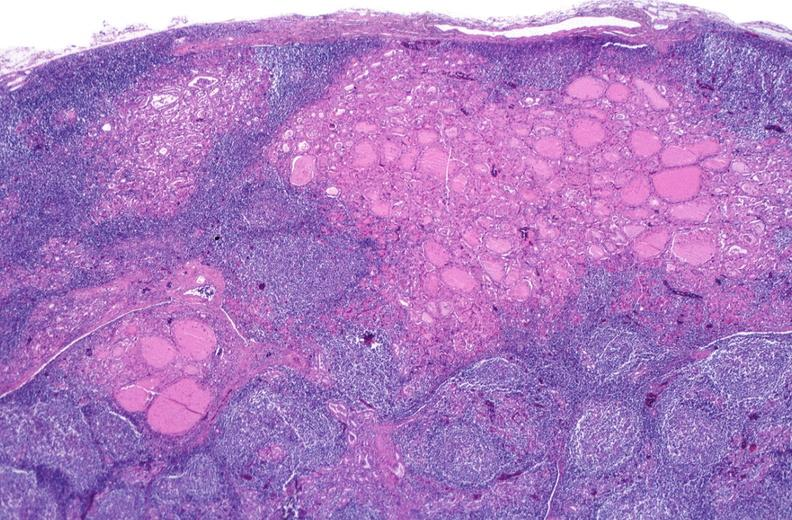what is present?
Answer the question using a single word or phrase. Endocrine 